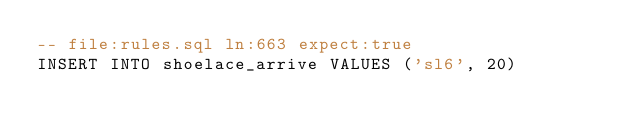<code> <loc_0><loc_0><loc_500><loc_500><_SQL_>-- file:rules.sql ln:663 expect:true
INSERT INTO shoelace_arrive VALUES ('sl6', 20)
</code> 